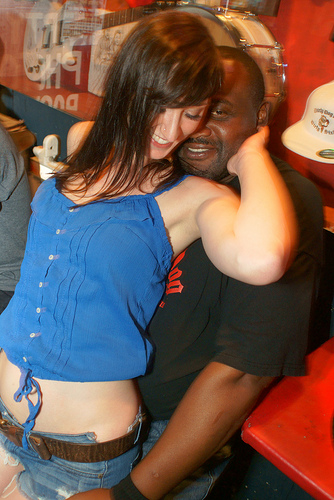<image>
Is the girl on the guy? Yes. Looking at the image, I can see the girl is positioned on top of the guy, with the guy providing support. 